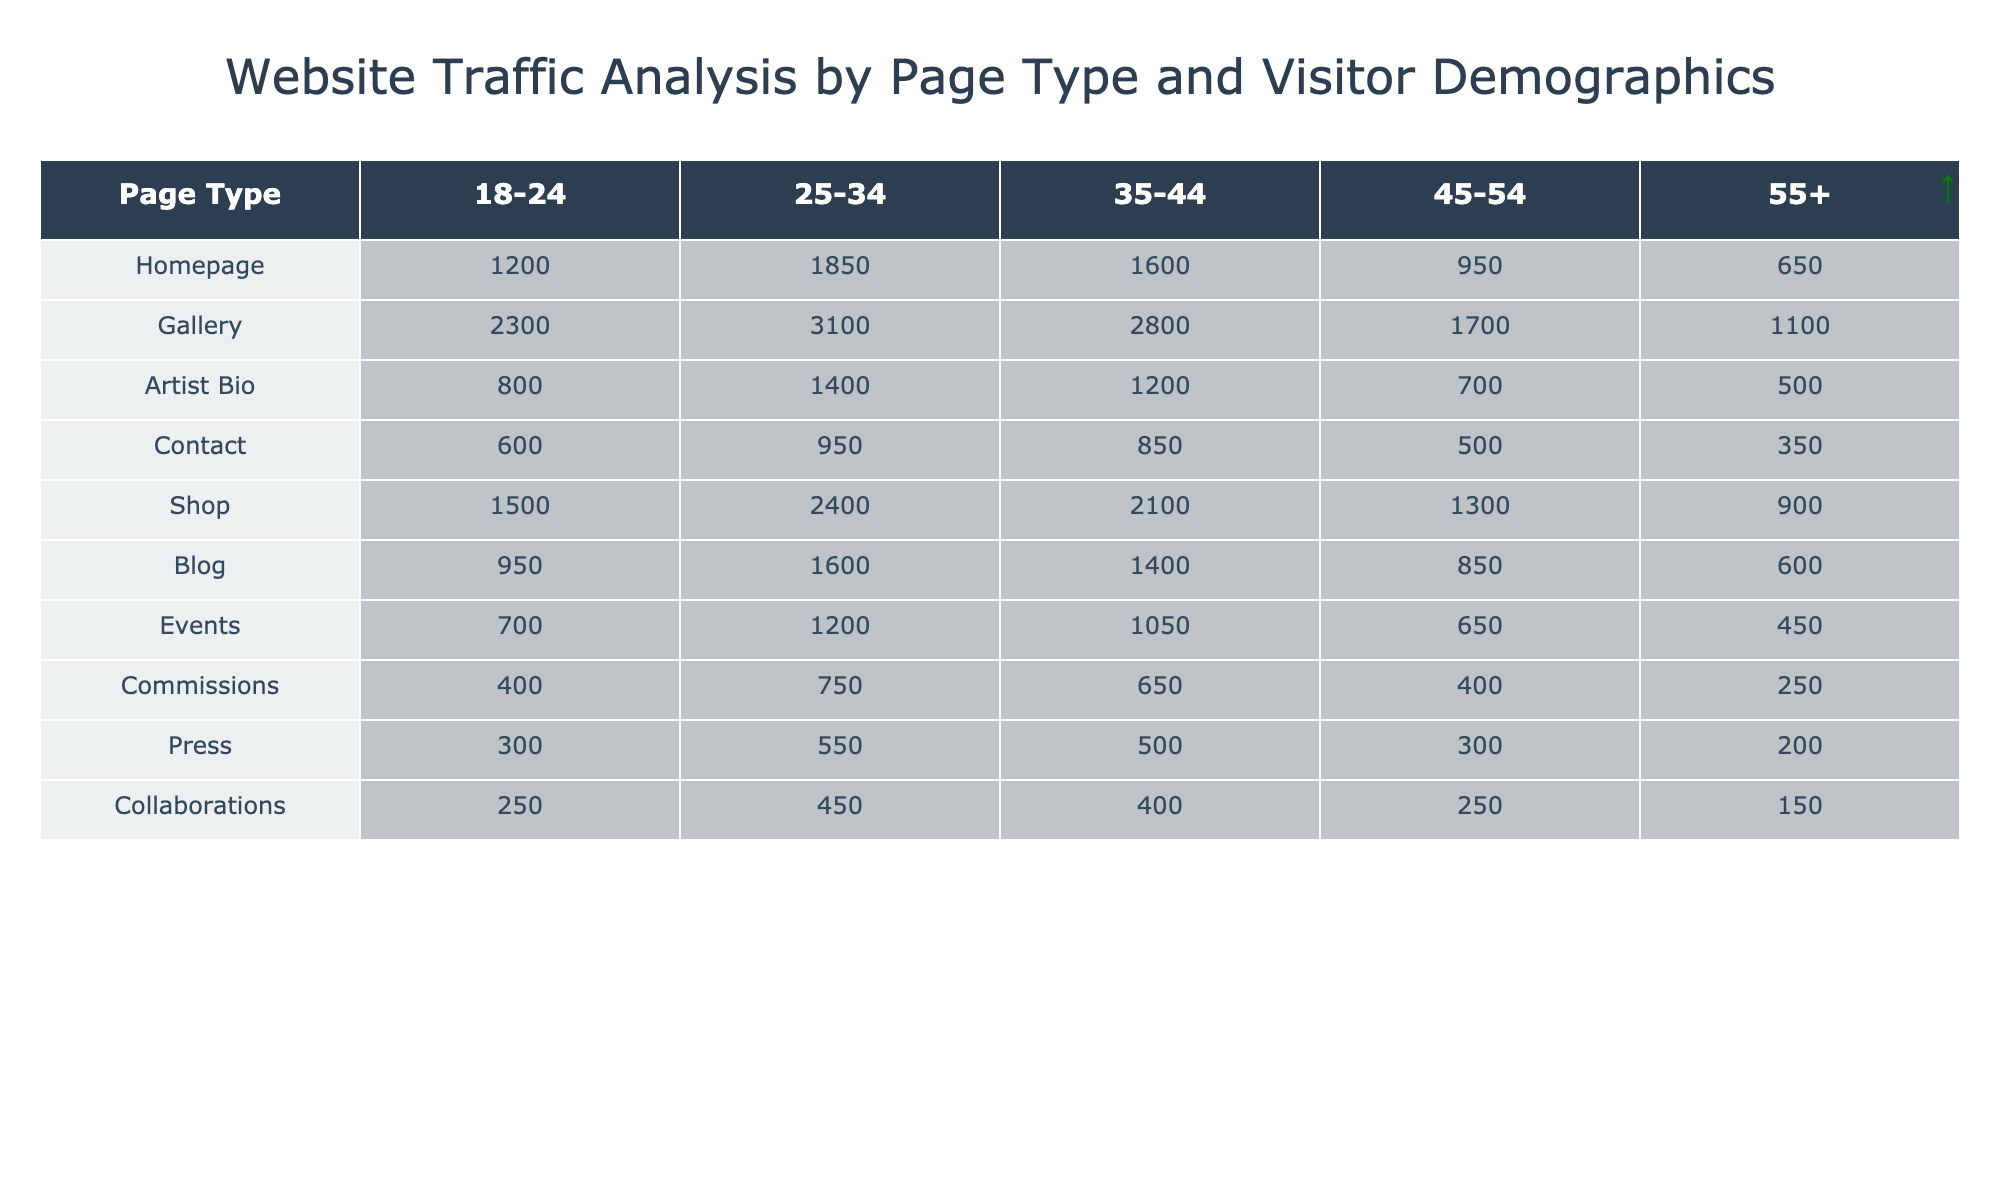What is the most visited page type among the 18-24 age group? Looking at the 18-24 age column, the Gallery has the highest value of 2300 visitors compared to other page types.
Answer: Gallery What is the least visited page type by the 55+ age group? Reviewing the 55+ age column, the page type with the minimum value is Collaborations, with only 150 visitors.
Answer: Collaborations How many total visitors accessed the Shop page across all age groups? Summing the visitors for the Shop page across all age groups gives: 1500 + 2400 + 2100 + 1300 + 900 = 10300.
Answer: 10300 Which age group had the highest overall visitation to the Homepage? The numbers for the Homepage by age groups are: 1200, 1850, 1600, 950, 650. The highest is 1850 from the 25-34 age group.
Answer: 25-34 What is the average number of visitors for the Artist Bio page by all age groups? Calculating the average involves summing: 800 + 1400 + 1200 + 700 + 500 = 3600, then dividing by 5 age groups, giving 3600 / 5 = 720.
Answer: 720 Is there a page type that has the same number of visitors for the 35-44 age group as the 45-54 age group? Checking the columns, the Gallery has 2800 visitors for 35-44 and the Shop has 1300 for 45-54, but there are no matches for the same visitor count in these age groups.
Answer: No Which page type saw the highest drop in visitor numbers from the 25-34 age group to the 55+ age group? Looking at the data for each page type, the largest difference is for the Gallery: 3100 (25-34) - 1100 (55+) = 2000.
Answer: Gallery What percentage of the total visitors to the Blog page were between the ages of 25-34? First, total Blog visitors across groups are 950 + 1600 + 1400 + 850 + 600 = 4350. For age 25-34, visitors are 1600. The percentage calculation is (1600 / 4350) * 100 ≈ 36.78%.
Answer: 36.78% Among the different age groups, which visitor group is most likely to visit the Commissions page? For Commissions, the numbers are: 400 (18-24), 750 (25-34), 650 (35-44), 400 (45-54), and 250 (55+). The highest count is from the 25-34 age group with 750 visitors.
Answer: 25-34 What is the difference in the number of visitors between the Gallery and the Shop for the 45-54 age group? The Gallery had 1700 visitors and the Shop had 1300 visitors for the 45-54 group, so the difference is 1700 - 1300 = 400.
Answer: 400 